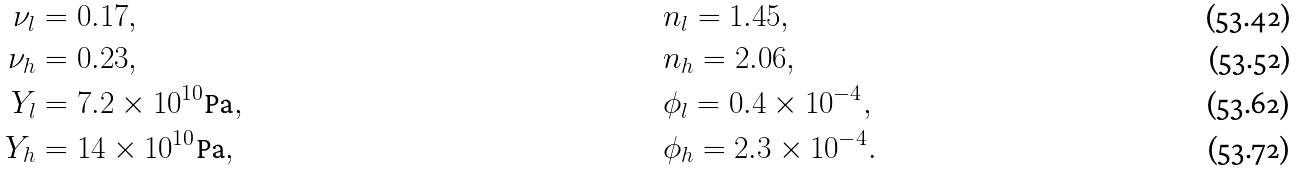Convert formula to latex. <formula><loc_0><loc_0><loc_500><loc_500>\nu _ { l } & = 0 . 1 7 , & \ & n _ { l } = 1 . 4 5 , \\ \nu _ { h } & = 0 . 2 3 , & \ & n _ { h } = 2 . 0 6 , \\ Y _ { l } & = 7 . 2 \times 1 0 ^ { 1 0 } \text {Pa} , & \ & \phi _ { l } = 0 . 4 \times 1 0 ^ { - 4 } , \\ Y _ { h } & = 1 4 \times 1 0 ^ { 1 0 } \text {Pa} , & \ & \phi _ { h } = 2 . 3 \times 1 0 ^ { - 4 } .</formula> 